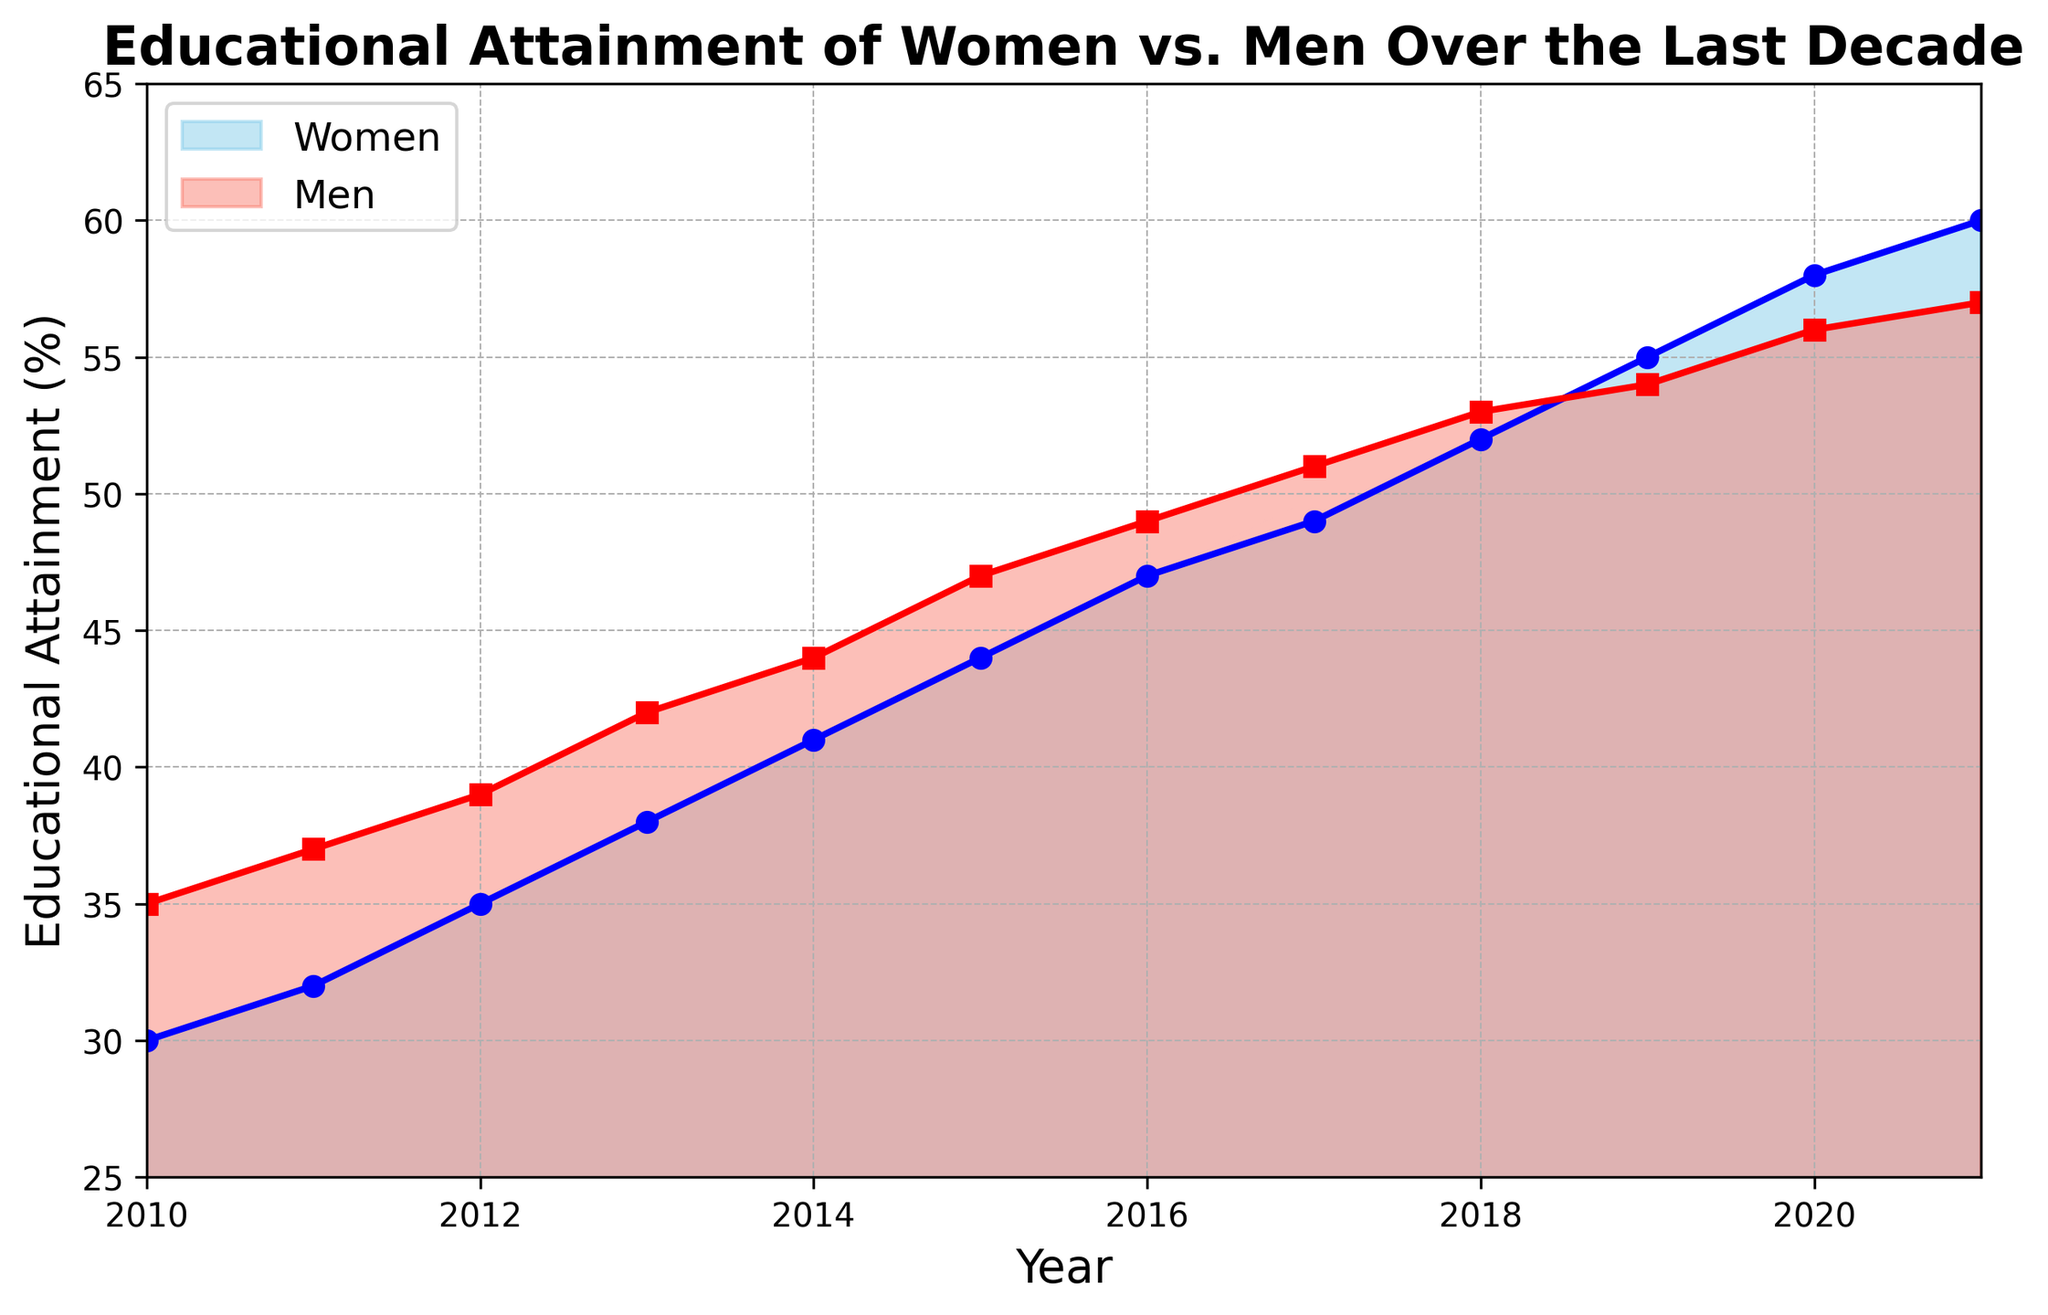What is the percentage difference in educational attainment between women and men in 2010? In 2010, the educational attainment for women is 30% and for men is 35%. The difference is calculated as 35 - 30 = 5%.
Answer: 5% Did women ever surpass men in educational attainment during this period? If so, in which year did it first occur? Yes, women surpassed men in educational attainment in 2019. In that year, women had 55% and men had 54%.
Answer: 2019 In which year was the gap between women and men's educational attainment the largest? By observing the heights of the two shaded areas, the largest gap appears in 2010 when men had 35% and women had 30%, resulting in a gap of 5%.
Answer: 2010 What was the average educational attainment for women over the entire period? Sum the percentages for women from 2010 to 2021 (30+32+35+38+41+44+47+49+52+55+58+60 = 491) and divide by the number of years (12). The average is 491/12 ≈ 40.92%.
Answer: 40.92% In 2015, how much more percentage points did men have compared to women in educational attainment? In 2015, men had 47% and women had 44%. The difference is calculated as 47 - 44 = 3%.
Answer: 3% What is the average growth rate in educational attainment for women from 2010 to 2021? Calculate the total increase for women (60 - 30 = 30%) and divide by the number of years minus one (2021-2010 = 11). The average growth rate is 30/11 ≈ 2.73% per year.
Answer: 2.73% Which year had the smallest gap in educational attainment between women and men? In 2021, the gap is smallest, with women at 60% and men at 57%, resulting in a difference of 3%.
Answer: 2021 From 2010 to 2021, which gender showed a more consistent trend in educational attainment, and how can you tell? Both genders showed a steady increase, but women had a slightly more consistent trend as displayed by the smoothly increasing curve as compared to men. However, from 2012 onwards, both trends are fairly consistent. Focus on overall smoother and less fluctuating pattern.
Answer: Women 